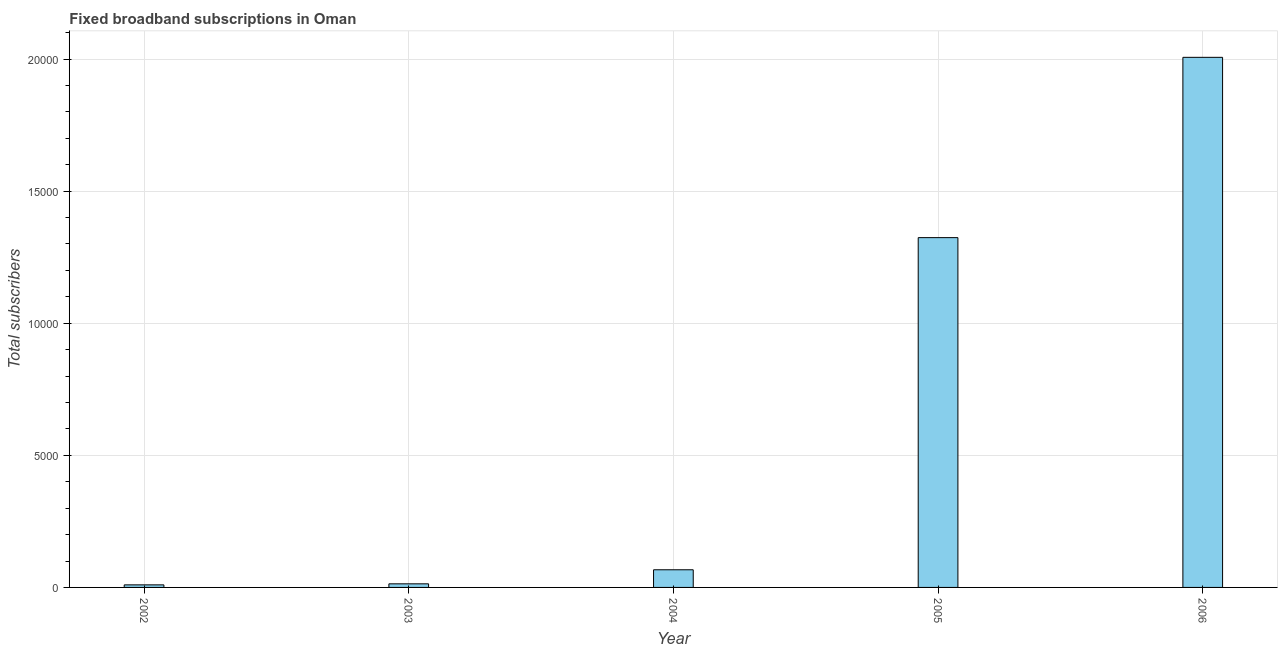Does the graph contain grids?
Make the answer very short. Yes. What is the title of the graph?
Your response must be concise. Fixed broadband subscriptions in Oman. What is the label or title of the Y-axis?
Keep it short and to the point. Total subscribers. What is the total number of fixed broadband subscriptions in 2006?
Ensure brevity in your answer.  2.01e+04. Across all years, what is the maximum total number of fixed broadband subscriptions?
Your answer should be compact. 2.01e+04. Across all years, what is the minimum total number of fixed broadband subscriptions?
Make the answer very short. 97. In which year was the total number of fixed broadband subscriptions maximum?
Offer a very short reply. 2006. In which year was the total number of fixed broadband subscriptions minimum?
Your response must be concise. 2002. What is the sum of the total number of fixed broadband subscriptions?
Offer a terse response. 3.42e+04. What is the difference between the total number of fixed broadband subscriptions in 2004 and 2005?
Offer a very short reply. -1.26e+04. What is the average total number of fixed broadband subscriptions per year?
Provide a succinct answer. 6841. What is the median total number of fixed broadband subscriptions?
Ensure brevity in your answer.  668. What is the ratio of the total number of fixed broadband subscriptions in 2004 to that in 2006?
Offer a terse response. 0.03. What is the difference between the highest and the second highest total number of fixed broadband subscriptions?
Your response must be concise. 6825. What is the difference between the highest and the lowest total number of fixed broadband subscriptions?
Your response must be concise. 2.00e+04. What is the Total subscribers of 2002?
Ensure brevity in your answer.  97. What is the Total subscribers of 2003?
Keep it short and to the point. 136. What is the Total subscribers in 2004?
Provide a succinct answer. 668. What is the Total subscribers of 2005?
Ensure brevity in your answer.  1.32e+04. What is the Total subscribers in 2006?
Provide a short and direct response. 2.01e+04. What is the difference between the Total subscribers in 2002 and 2003?
Provide a succinct answer. -39. What is the difference between the Total subscribers in 2002 and 2004?
Provide a succinct answer. -571. What is the difference between the Total subscribers in 2002 and 2005?
Provide a short and direct response. -1.31e+04. What is the difference between the Total subscribers in 2002 and 2006?
Offer a very short reply. -2.00e+04. What is the difference between the Total subscribers in 2003 and 2004?
Provide a short and direct response. -532. What is the difference between the Total subscribers in 2003 and 2005?
Offer a very short reply. -1.31e+04. What is the difference between the Total subscribers in 2003 and 2006?
Your answer should be compact. -1.99e+04. What is the difference between the Total subscribers in 2004 and 2005?
Provide a short and direct response. -1.26e+04. What is the difference between the Total subscribers in 2004 and 2006?
Offer a very short reply. -1.94e+04. What is the difference between the Total subscribers in 2005 and 2006?
Offer a very short reply. -6825. What is the ratio of the Total subscribers in 2002 to that in 2003?
Give a very brief answer. 0.71. What is the ratio of the Total subscribers in 2002 to that in 2004?
Keep it short and to the point. 0.14. What is the ratio of the Total subscribers in 2002 to that in 2005?
Give a very brief answer. 0.01. What is the ratio of the Total subscribers in 2002 to that in 2006?
Provide a succinct answer. 0.01. What is the ratio of the Total subscribers in 2003 to that in 2004?
Provide a succinct answer. 0.2. What is the ratio of the Total subscribers in 2003 to that in 2006?
Offer a very short reply. 0.01. What is the ratio of the Total subscribers in 2004 to that in 2006?
Provide a short and direct response. 0.03. What is the ratio of the Total subscribers in 2005 to that in 2006?
Give a very brief answer. 0.66. 